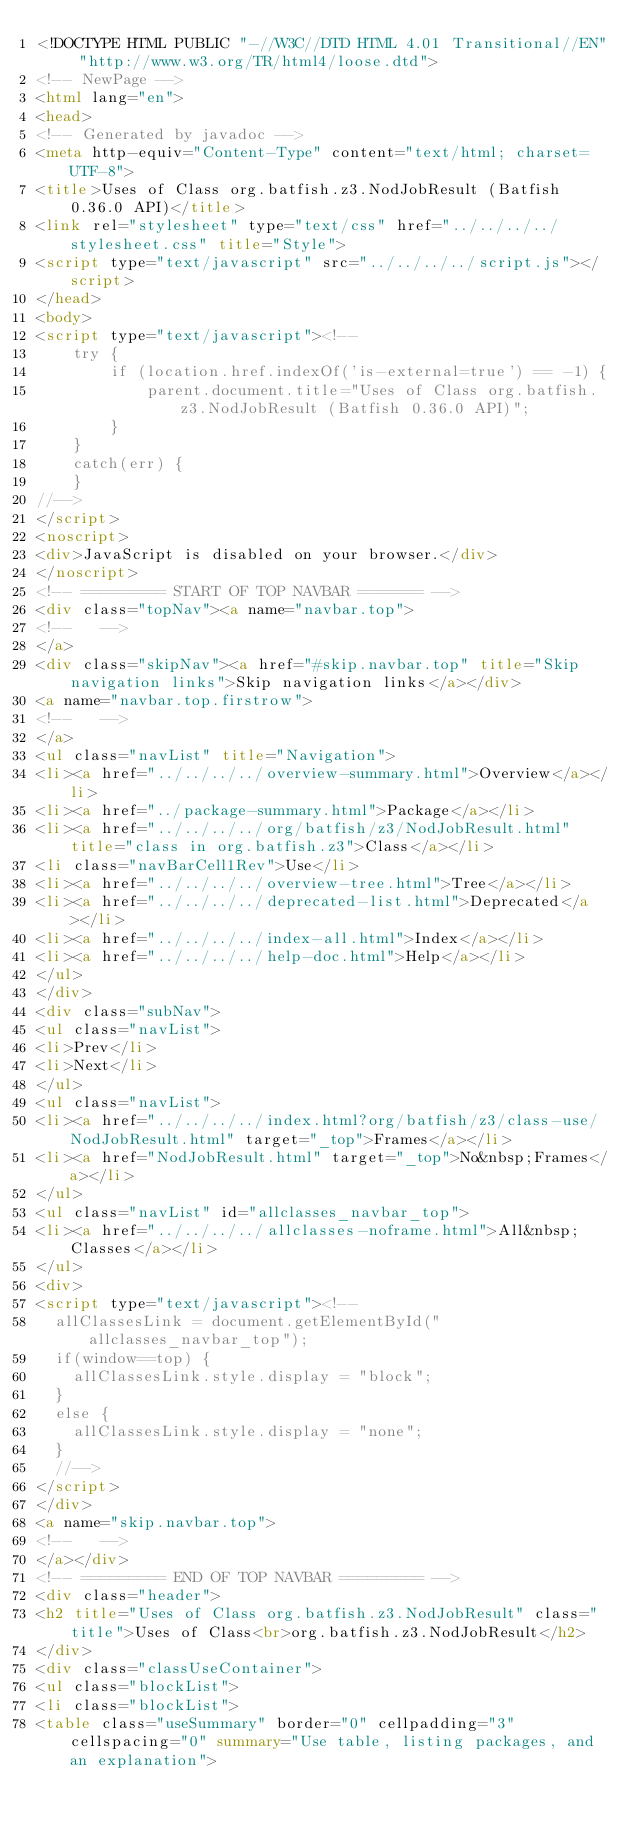<code> <loc_0><loc_0><loc_500><loc_500><_HTML_><!DOCTYPE HTML PUBLIC "-//W3C//DTD HTML 4.01 Transitional//EN" "http://www.w3.org/TR/html4/loose.dtd">
<!-- NewPage -->
<html lang="en">
<head>
<!-- Generated by javadoc -->
<meta http-equiv="Content-Type" content="text/html; charset=UTF-8">
<title>Uses of Class org.batfish.z3.NodJobResult (Batfish 0.36.0 API)</title>
<link rel="stylesheet" type="text/css" href="../../../../stylesheet.css" title="Style">
<script type="text/javascript" src="../../../../script.js"></script>
</head>
<body>
<script type="text/javascript"><!--
    try {
        if (location.href.indexOf('is-external=true') == -1) {
            parent.document.title="Uses of Class org.batfish.z3.NodJobResult (Batfish 0.36.0 API)";
        }
    }
    catch(err) {
    }
//-->
</script>
<noscript>
<div>JavaScript is disabled on your browser.</div>
</noscript>
<!-- ========= START OF TOP NAVBAR ======= -->
<div class="topNav"><a name="navbar.top">
<!--   -->
</a>
<div class="skipNav"><a href="#skip.navbar.top" title="Skip navigation links">Skip navigation links</a></div>
<a name="navbar.top.firstrow">
<!--   -->
</a>
<ul class="navList" title="Navigation">
<li><a href="../../../../overview-summary.html">Overview</a></li>
<li><a href="../package-summary.html">Package</a></li>
<li><a href="../../../../org/batfish/z3/NodJobResult.html" title="class in org.batfish.z3">Class</a></li>
<li class="navBarCell1Rev">Use</li>
<li><a href="../../../../overview-tree.html">Tree</a></li>
<li><a href="../../../../deprecated-list.html">Deprecated</a></li>
<li><a href="../../../../index-all.html">Index</a></li>
<li><a href="../../../../help-doc.html">Help</a></li>
</ul>
</div>
<div class="subNav">
<ul class="navList">
<li>Prev</li>
<li>Next</li>
</ul>
<ul class="navList">
<li><a href="../../../../index.html?org/batfish/z3/class-use/NodJobResult.html" target="_top">Frames</a></li>
<li><a href="NodJobResult.html" target="_top">No&nbsp;Frames</a></li>
</ul>
<ul class="navList" id="allclasses_navbar_top">
<li><a href="../../../../allclasses-noframe.html">All&nbsp;Classes</a></li>
</ul>
<div>
<script type="text/javascript"><!--
  allClassesLink = document.getElementById("allclasses_navbar_top");
  if(window==top) {
    allClassesLink.style.display = "block";
  }
  else {
    allClassesLink.style.display = "none";
  }
  //-->
</script>
</div>
<a name="skip.navbar.top">
<!--   -->
</a></div>
<!-- ========= END OF TOP NAVBAR ========= -->
<div class="header">
<h2 title="Uses of Class org.batfish.z3.NodJobResult" class="title">Uses of Class<br>org.batfish.z3.NodJobResult</h2>
</div>
<div class="classUseContainer">
<ul class="blockList">
<li class="blockList">
<table class="useSummary" border="0" cellpadding="3" cellspacing="0" summary="Use table, listing packages, and an explanation"></code> 